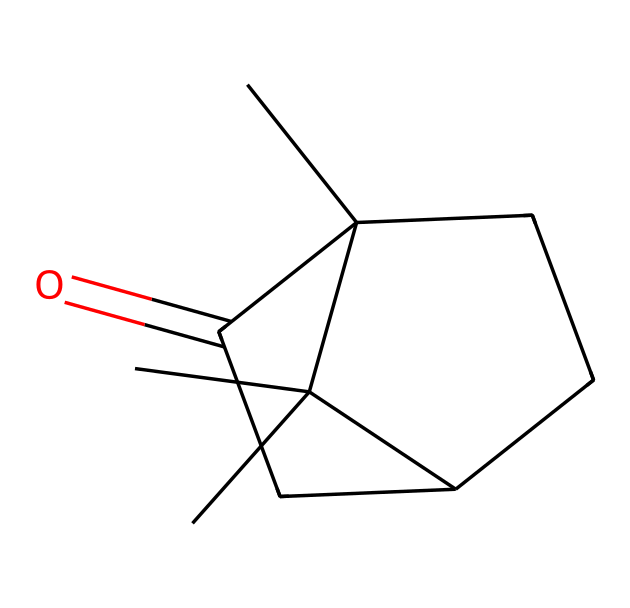What is the chemical name of this compound? The SMILES representation shows a structure that corresponds to camphor, a well-known terpenoid ketone used in traditional medicine.
Answer: camphor How many carbon atoms are in the molecule? By analyzing the SMILES, we count the number of 'C' characters, which indicates there are ten carbon atoms in the structure.
Answer: ten What functional group is present in this compound? The carbonyl group (C=O) is what characterizes ketones. In the SMILES, we can see a carbon atom double-bonded to an oxygen, indicating the presence of a ketone functional group.
Answer: ketone Is this compound saturated or unsaturated? The presence of double bonds in the structure signifies that it has unsaturation. The SMILES indicates that there are rings and double bonds, which denotes an unsaturated compound.
Answer: unsaturated What type of isomerism might camphor exhibit? Given that camphor has multiple stereocenters (as seen in its structure), it can exist in different stereoisomeric forms, such as enantiomers.
Answer: stereoisomerism What is the molecular formula of camphor? Upon translating the structure from the SMILES, we derive the specific counts of each atom (C, H, O) to find the molecular formula is C10H16O.
Answer: C10H16O 